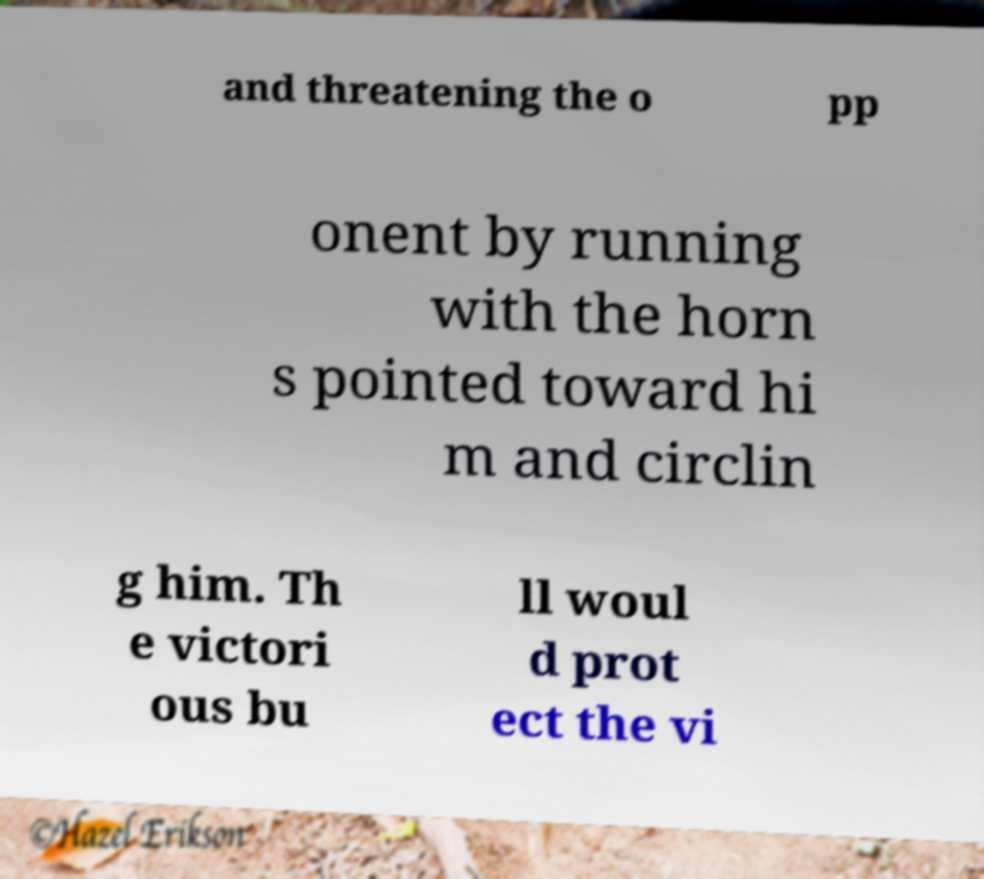Could you assist in decoding the text presented in this image and type it out clearly? and threatening the o pp onent by running with the horn s pointed toward hi m and circlin g him. Th e victori ous bu ll woul d prot ect the vi 